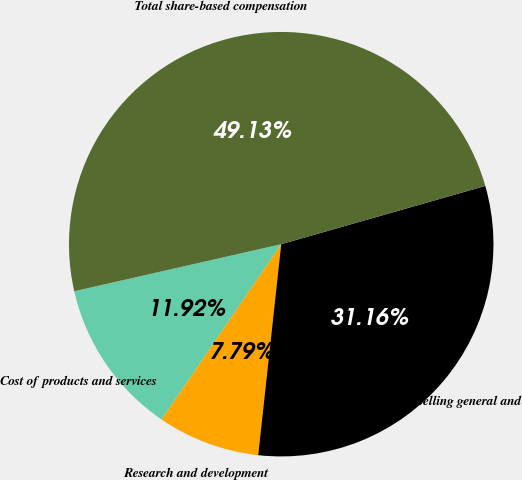Convert chart to OTSL. <chart><loc_0><loc_0><loc_500><loc_500><pie_chart><fcel>Cost of products and services<fcel>Research and development<fcel>Selling general and<fcel>Total share-based compensation<nl><fcel>11.92%<fcel>7.79%<fcel>31.16%<fcel>49.13%<nl></chart> 